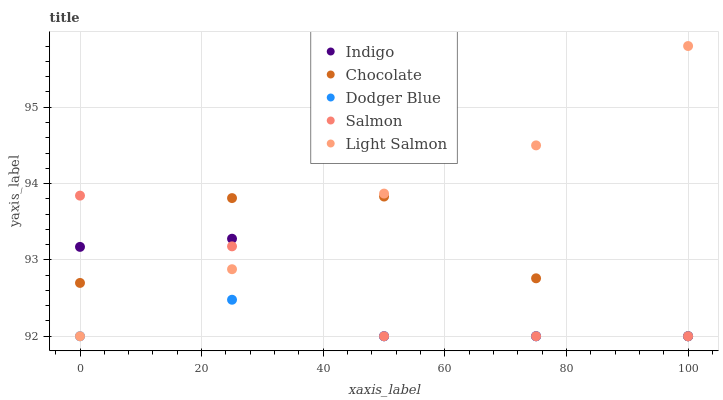Does Dodger Blue have the minimum area under the curve?
Answer yes or no. Yes. Does Light Salmon have the maximum area under the curve?
Answer yes or no. Yes. Does Salmon have the minimum area under the curve?
Answer yes or no. No. Does Salmon have the maximum area under the curve?
Answer yes or no. No. Is Light Salmon the smoothest?
Answer yes or no. Yes. Is Indigo the roughest?
Answer yes or no. Yes. Is Salmon the smoothest?
Answer yes or no. No. Is Salmon the roughest?
Answer yes or no. No. Does Dodger Blue have the lowest value?
Answer yes or no. Yes. Does Light Salmon have the highest value?
Answer yes or no. Yes. Does Salmon have the highest value?
Answer yes or no. No. Does Salmon intersect Indigo?
Answer yes or no. Yes. Is Salmon less than Indigo?
Answer yes or no. No. Is Salmon greater than Indigo?
Answer yes or no. No. 